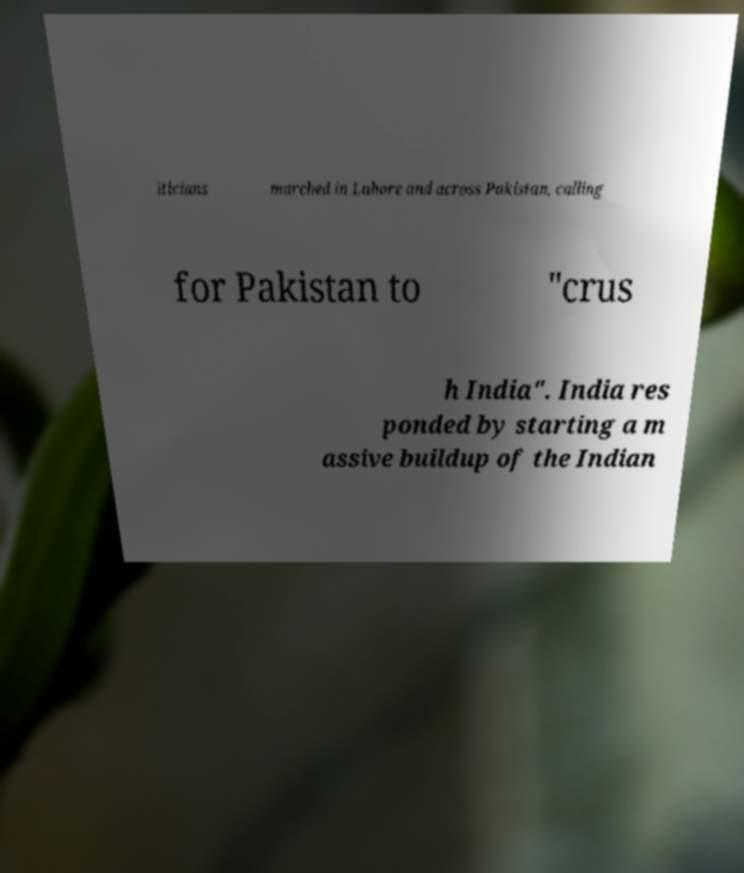For documentation purposes, I need the text within this image transcribed. Could you provide that? iticians marched in Lahore and across Pakistan, calling for Pakistan to "crus h India". India res ponded by starting a m assive buildup of the Indian 